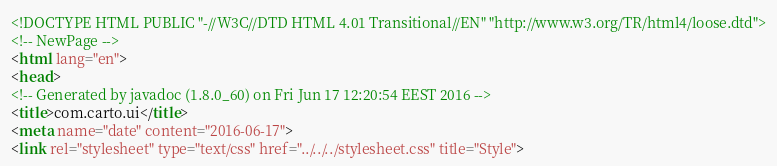Convert code to text. <code><loc_0><loc_0><loc_500><loc_500><_HTML_><!DOCTYPE HTML PUBLIC "-//W3C//DTD HTML 4.01 Transitional//EN" "http://www.w3.org/TR/html4/loose.dtd">
<!-- NewPage -->
<html lang="en">
<head>
<!-- Generated by javadoc (1.8.0_60) on Fri Jun 17 12:20:54 EEST 2016 -->
<title>com.carto.ui</title>
<meta name="date" content="2016-06-17">
<link rel="stylesheet" type="text/css" href="../../../stylesheet.css" title="Style"></code> 